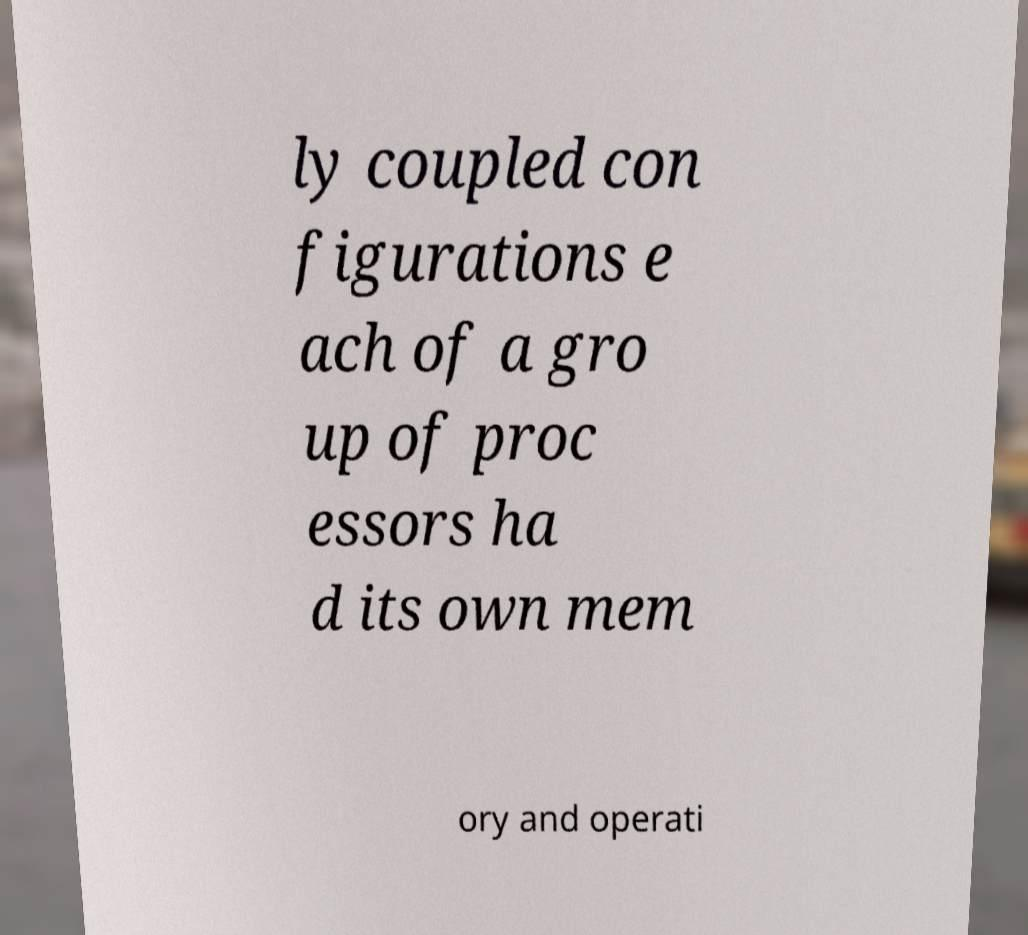Please read and relay the text visible in this image. What does it say? ly coupled con figurations e ach of a gro up of proc essors ha d its own mem ory and operati 